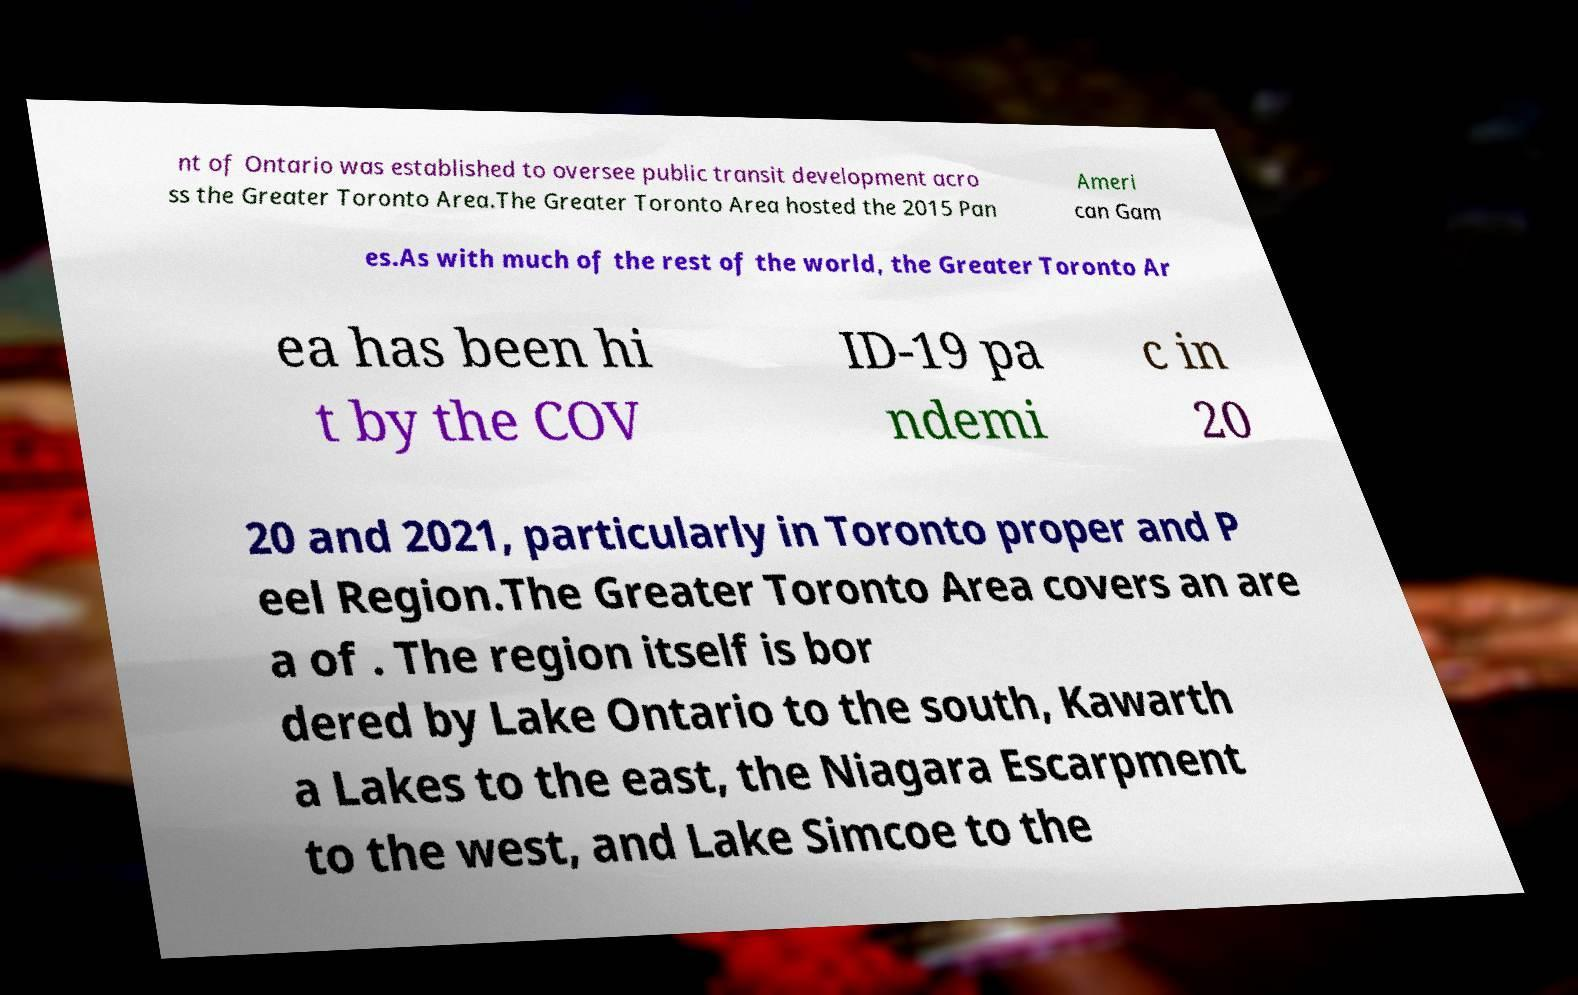Could you assist in decoding the text presented in this image and type it out clearly? nt of Ontario was established to oversee public transit development acro ss the Greater Toronto Area.The Greater Toronto Area hosted the 2015 Pan Ameri can Gam es.As with much of the rest of the world, the Greater Toronto Ar ea has been hi t by the COV ID-19 pa ndemi c in 20 20 and 2021, particularly in Toronto proper and P eel Region.The Greater Toronto Area covers an are a of . The region itself is bor dered by Lake Ontario to the south, Kawarth a Lakes to the east, the Niagara Escarpment to the west, and Lake Simcoe to the 